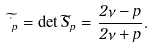Convert formula to latex. <formula><loc_0><loc_0><loc_500><loc_500>\widetilde { \Delta } _ { p } = \det \widetilde { S } _ { p } = \frac { 2 \nu - p } { 2 \nu + p } .</formula> 